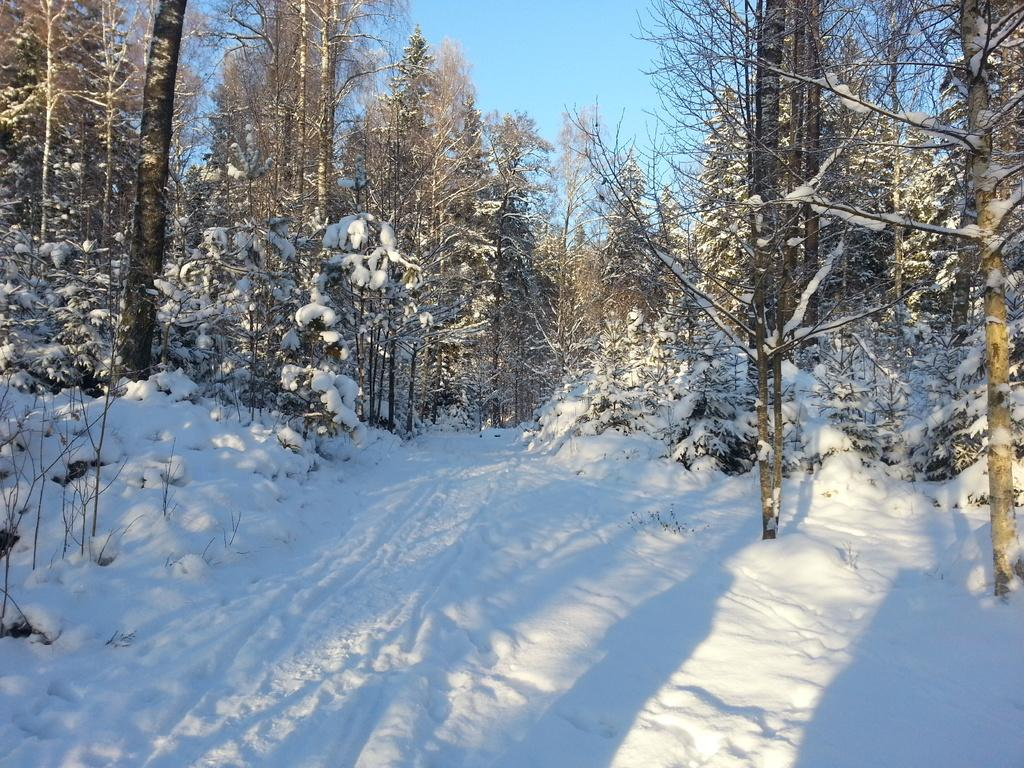What type of vegetation can be seen in the image? There are trees in the image. What is covering the ground in the image? The ground is covered with snow. What part of the natural environment is visible in the image? The sky is visible in the image. Can you see any animals from the zoo in the image? There is no zoo or animals present in the image; it features trees, snow-covered ground, and a visible sky. Are there any bubbles visible in the image? There are no bubbles present in the image. 